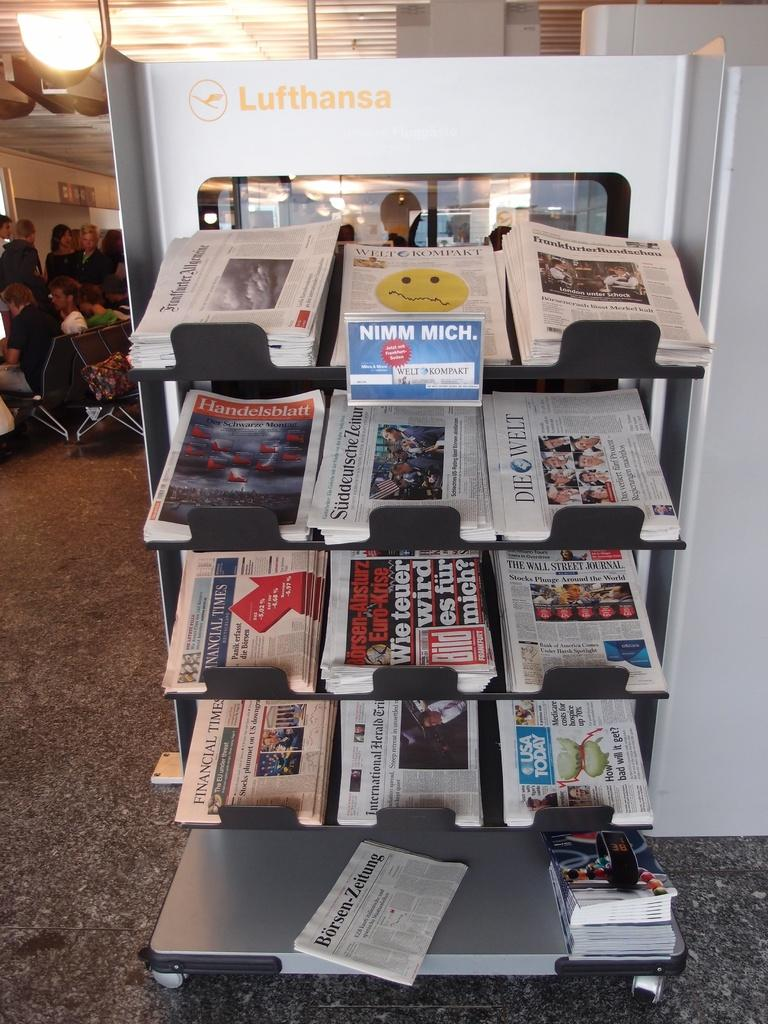<image>
Present a compact description of the photo's key features. A newspaper stand with 12 different papers and a sign that states NUMM MICH. 